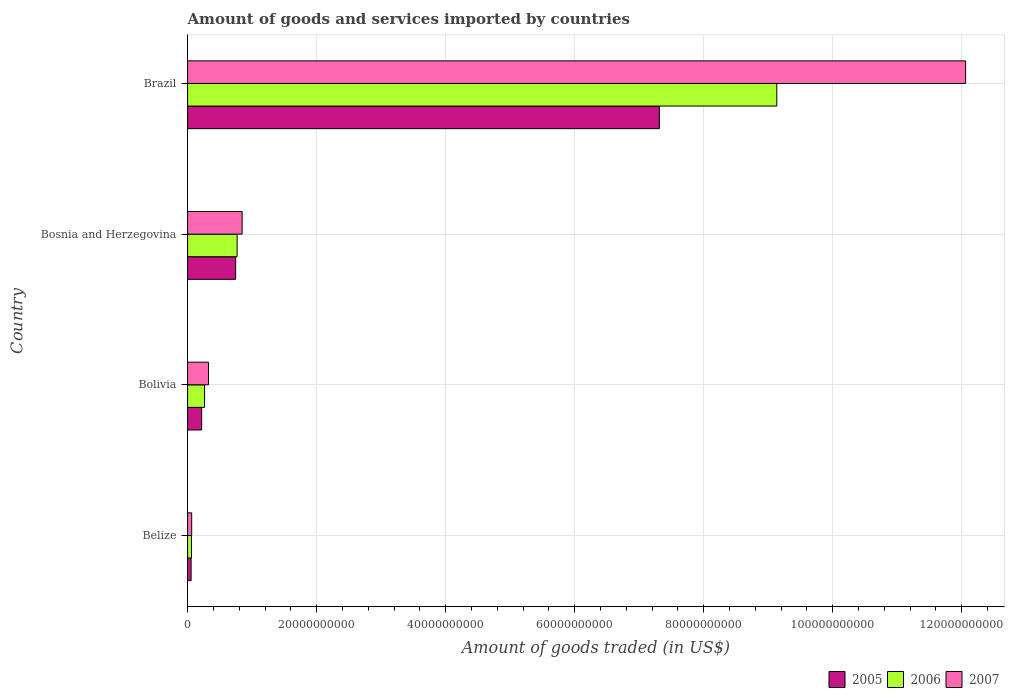How many different coloured bars are there?
Ensure brevity in your answer.  3. Are the number of bars per tick equal to the number of legend labels?
Provide a succinct answer. Yes. Are the number of bars on each tick of the Y-axis equal?
Offer a terse response. Yes. How many bars are there on the 3rd tick from the top?
Your response must be concise. 3. What is the label of the 1st group of bars from the top?
Your answer should be very brief. Brazil. What is the total amount of goods and services imported in 2005 in Bosnia and Herzegovina?
Offer a terse response. 7.45e+09. Across all countries, what is the maximum total amount of goods and services imported in 2006?
Provide a succinct answer. 9.13e+1. Across all countries, what is the minimum total amount of goods and services imported in 2007?
Your answer should be compact. 6.35e+08. In which country was the total amount of goods and services imported in 2006 minimum?
Give a very brief answer. Belize. What is the total total amount of goods and services imported in 2006 in the graph?
Your answer should be compact. 1.02e+11. What is the difference between the total amount of goods and services imported in 2007 in Belize and that in Bosnia and Herzegovina?
Your response must be concise. -7.82e+09. What is the difference between the total amount of goods and services imported in 2007 in Bosnia and Herzegovina and the total amount of goods and services imported in 2006 in Brazil?
Keep it short and to the point. -8.29e+1. What is the average total amount of goods and services imported in 2005 per country?
Your response must be concise. 2.08e+1. What is the difference between the total amount of goods and services imported in 2007 and total amount of goods and services imported in 2006 in Bolivia?
Your answer should be compact. 6.11e+08. What is the ratio of the total amount of goods and services imported in 2007 in Bolivia to that in Bosnia and Herzegovina?
Provide a short and direct response. 0.38. Is the total amount of goods and services imported in 2006 in Belize less than that in Brazil?
Provide a short and direct response. Yes. What is the difference between the highest and the second highest total amount of goods and services imported in 2006?
Your response must be concise. 8.37e+1. What is the difference between the highest and the lowest total amount of goods and services imported in 2006?
Keep it short and to the point. 9.08e+1. Is it the case that in every country, the sum of the total amount of goods and services imported in 2005 and total amount of goods and services imported in 2006 is greater than the total amount of goods and services imported in 2007?
Make the answer very short. Yes. Are all the bars in the graph horizontal?
Your answer should be very brief. Yes. How many countries are there in the graph?
Offer a terse response. 4. What is the difference between two consecutive major ticks on the X-axis?
Your response must be concise. 2.00e+1. Are the values on the major ticks of X-axis written in scientific E-notation?
Your response must be concise. No. Does the graph contain any zero values?
Provide a short and direct response. No. Does the graph contain grids?
Provide a short and direct response. Yes. What is the title of the graph?
Your answer should be very brief. Amount of goods and services imported by countries. Does "1982" appear as one of the legend labels in the graph?
Keep it short and to the point. No. What is the label or title of the X-axis?
Your answer should be compact. Amount of goods traded (in US$). What is the Amount of goods traded (in US$) of 2005 in Belize?
Make the answer very short. 5.44e+08. What is the Amount of goods traded (in US$) in 2006 in Belize?
Ensure brevity in your answer.  5.98e+08. What is the Amount of goods traded (in US$) in 2007 in Belize?
Ensure brevity in your answer.  6.35e+08. What is the Amount of goods traded (in US$) in 2005 in Bolivia?
Give a very brief answer. 2.18e+09. What is the Amount of goods traded (in US$) of 2006 in Bolivia?
Your answer should be compact. 2.63e+09. What is the Amount of goods traded (in US$) of 2007 in Bolivia?
Your answer should be very brief. 3.24e+09. What is the Amount of goods traded (in US$) in 2005 in Bosnia and Herzegovina?
Give a very brief answer. 7.45e+09. What is the Amount of goods traded (in US$) in 2006 in Bosnia and Herzegovina?
Keep it short and to the point. 7.68e+09. What is the Amount of goods traded (in US$) of 2007 in Bosnia and Herzegovina?
Your answer should be compact. 8.45e+09. What is the Amount of goods traded (in US$) in 2005 in Brazil?
Keep it short and to the point. 7.31e+1. What is the Amount of goods traded (in US$) of 2006 in Brazil?
Offer a terse response. 9.13e+1. What is the Amount of goods traded (in US$) of 2007 in Brazil?
Your response must be concise. 1.21e+11. Across all countries, what is the maximum Amount of goods traded (in US$) of 2005?
Offer a very short reply. 7.31e+1. Across all countries, what is the maximum Amount of goods traded (in US$) in 2006?
Offer a terse response. 9.13e+1. Across all countries, what is the maximum Amount of goods traded (in US$) of 2007?
Offer a terse response. 1.21e+11. Across all countries, what is the minimum Amount of goods traded (in US$) of 2005?
Offer a very short reply. 5.44e+08. Across all countries, what is the minimum Amount of goods traded (in US$) of 2006?
Your response must be concise. 5.98e+08. Across all countries, what is the minimum Amount of goods traded (in US$) in 2007?
Offer a terse response. 6.35e+08. What is the total Amount of goods traded (in US$) in 2005 in the graph?
Offer a terse response. 8.33e+1. What is the total Amount of goods traded (in US$) in 2006 in the graph?
Ensure brevity in your answer.  1.02e+11. What is the total Amount of goods traded (in US$) in 2007 in the graph?
Offer a very short reply. 1.33e+11. What is the difference between the Amount of goods traded (in US$) of 2005 in Belize and that in Bolivia?
Provide a succinct answer. -1.64e+09. What is the difference between the Amount of goods traded (in US$) in 2006 in Belize and that in Bolivia?
Make the answer very short. -2.03e+09. What is the difference between the Amount of goods traded (in US$) in 2007 in Belize and that in Bolivia?
Offer a terse response. -2.61e+09. What is the difference between the Amount of goods traded (in US$) of 2005 in Belize and that in Bosnia and Herzegovina?
Provide a short and direct response. -6.91e+09. What is the difference between the Amount of goods traded (in US$) of 2006 in Belize and that in Bosnia and Herzegovina?
Provide a succinct answer. -7.08e+09. What is the difference between the Amount of goods traded (in US$) in 2007 in Belize and that in Bosnia and Herzegovina?
Provide a succinct answer. -7.82e+09. What is the difference between the Amount of goods traded (in US$) in 2005 in Belize and that in Brazil?
Give a very brief answer. -7.26e+1. What is the difference between the Amount of goods traded (in US$) in 2006 in Belize and that in Brazil?
Offer a terse response. -9.08e+1. What is the difference between the Amount of goods traded (in US$) in 2007 in Belize and that in Brazil?
Your answer should be compact. -1.20e+11. What is the difference between the Amount of goods traded (in US$) in 2005 in Bolivia and that in Bosnia and Herzegovina?
Offer a very short reply. -5.27e+09. What is the difference between the Amount of goods traded (in US$) in 2006 in Bolivia and that in Bosnia and Herzegovina?
Give a very brief answer. -5.05e+09. What is the difference between the Amount of goods traded (in US$) of 2007 in Bolivia and that in Bosnia and Herzegovina?
Give a very brief answer. -5.21e+09. What is the difference between the Amount of goods traded (in US$) in 2005 in Bolivia and that in Brazil?
Offer a terse response. -7.10e+1. What is the difference between the Amount of goods traded (in US$) in 2006 in Bolivia and that in Brazil?
Offer a very short reply. -8.87e+1. What is the difference between the Amount of goods traded (in US$) of 2007 in Bolivia and that in Brazil?
Offer a terse response. -1.17e+11. What is the difference between the Amount of goods traded (in US$) in 2005 in Bosnia and Herzegovina and that in Brazil?
Your response must be concise. -6.57e+1. What is the difference between the Amount of goods traded (in US$) in 2006 in Bosnia and Herzegovina and that in Brazil?
Make the answer very short. -8.37e+1. What is the difference between the Amount of goods traded (in US$) of 2007 in Bosnia and Herzegovina and that in Brazil?
Give a very brief answer. -1.12e+11. What is the difference between the Amount of goods traded (in US$) in 2005 in Belize and the Amount of goods traded (in US$) in 2006 in Bolivia?
Keep it short and to the point. -2.09e+09. What is the difference between the Amount of goods traded (in US$) in 2005 in Belize and the Amount of goods traded (in US$) in 2007 in Bolivia?
Your answer should be compact. -2.70e+09. What is the difference between the Amount of goods traded (in US$) of 2006 in Belize and the Amount of goods traded (in US$) of 2007 in Bolivia?
Keep it short and to the point. -2.65e+09. What is the difference between the Amount of goods traded (in US$) of 2005 in Belize and the Amount of goods traded (in US$) of 2006 in Bosnia and Herzegovina?
Give a very brief answer. -7.14e+09. What is the difference between the Amount of goods traded (in US$) of 2005 in Belize and the Amount of goods traded (in US$) of 2007 in Bosnia and Herzegovina?
Provide a succinct answer. -7.91e+09. What is the difference between the Amount of goods traded (in US$) of 2006 in Belize and the Amount of goods traded (in US$) of 2007 in Bosnia and Herzegovina?
Provide a short and direct response. -7.86e+09. What is the difference between the Amount of goods traded (in US$) of 2005 in Belize and the Amount of goods traded (in US$) of 2006 in Brazil?
Give a very brief answer. -9.08e+1. What is the difference between the Amount of goods traded (in US$) in 2005 in Belize and the Amount of goods traded (in US$) in 2007 in Brazil?
Your answer should be compact. -1.20e+11. What is the difference between the Amount of goods traded (in US$) of 2006 in Belize and the Amount of goods traded (in US$) of 2007 in Brazil?
Your answer should be very brief. -1.20e+11. What is the difference between the Amount of goods traded (in US$) of 2005 in Bolivia and the Amount of goods traded (in US$) of 2006 in Bosnia and Herzegovina?
Your answer should be very brief. -5.50e+09. What is the difference between the Amount of goods traded (in US$) of 2005 in Bolivia and the Amount of goods traded (in US$) of 2007 in Bosnia and Herzegovina?
Keep it short and to the point. -6.27e+09. What is the difference between the Amount of goods traded (in US$) of 2006 in Bolivia and the Amount of goods traded (in US$) of 2007 in Bosnia and Herzegovina?
Offer a very short reply. -5.82e+09. What is the difference between the Amount of goods traded (in US$) of 2005 in Bolivia and the Amount of goods traded (in US$) of 2006 in Brazil?
Make the answer very short. -8.92e+1. What is the difference between the Amount of goods traded (in US$) in 2005 in Bolivia and the Amount of goods traded (in US$) in 2007 in Brazil?
Offer a very short reply. -1.18e+11. What is the difference between the Amount of goods traded (in US$) of 2006 in Bolivia and the Amount of goods traded (in US$) of 2007 in Brazil?
Make the answer very short. -1.18e+11. What is the difference between the Amount of goods traded (in US$) of 2005 in Bosnia and Herzegovina and the Amount of goods traded (in US$) of 2006 in Brazil?
Ensure brevity in your answer.  -8.39e+1. What is the difference between the Amount of goods traded (in US$) of 2005 in Bosnia and Herzegovina and the Amount of goods traded (in US$) of 2007 in Brazil?
Offer a terse response. -1.13e+11. What is the difference between the Amount of goods traded (in US$) in 2006 in Bosnia and Herzegovina and the Amount of goods traded (in US$) in 2007 in Brazil?
Offer a very short reply. -1.13e+11. What is the average Amount of goods traded (in US$) of 2005 per country?
Offer a very short reply. 2.08e+1. What is the average Amount of goods traded (in US$) of 2006 per country?
Provide a succinct answer. 2.56e+1. What is the average Amount of goods traded (in US$) of 2007 per country?
Ensure brevity in your answer.  3.32e+1. What is the difference between the Amount of goods traded (in US$) of 2005 and Amount of goods traded (in US$) of 2006 in Belize?
Keep it short and to the point. -5.37e+07. What is the difference between the Amount of goods traded (in US$) in 2005 and Amount of goods traded (in US$) in 2007 in Belize?
Your answer should be very brief. -9.05e+07. What is the difference between the Amount of goods traded (in US$) in 2006 and Amount of goods traded (in US$) in 2007 in Belize?
Make the answer very short. -3.68e+07. What is the difference between the Amount of goods traded (in US$) of 2005 and Amount of goods traded (in US$) of 2006 in Bolivia?
Provide a succinct answer. -4.50e+08. What is the difference between the Amount of goods traded (in US$) of 2005 and Amount of goods traded (in US$) of 2007 in Bolivia?
Make the answer very short. -1.06e+09. What is the difference between the Amount of goods traded (in US$) in 2006 and Amount of goods traded (in US$) in 2007 in Bolivia?
Give a very brief answer. -6.11e+08. What is the difference between the Amount of goods traded (in US$) of 2005 and Amount of goods traded (in US$) of 2006 in Bosnia and Herzegovina?
Give a very brief answer. -2.25e+08. What is the difference between the Amount of goods traded (in US$) in 2005 and Amount of goods traded (in US$) in 2007 in Bosnia and Herzegovina?
Make the answer very short. -1.00e+09. What is the difference between the Amount of goods traded (in US$) of 2006 and Amount of goods traded (in US$) of 2007 in Bosnia and Herzegovina?
Ensure brevity in your answer.  -7.75e+08. What is the difference between the Amount of goods traded (in US$) in 2005 and Amount of goods traded (in US$) in 2006 in Brazil?
Offer a very short reply. -1.82e+1. What is the difference between the Amount of goods traded (in US$) of 2005 and Amount of goods traded (in US$) of 2007 in Brazil?
Offer a very short reply. -4.75e+1. What is the difference between the Amount of goods traded (in US$) of 2006 and Amount of goods traded (in US$) of 2007 in Brazil?
Your answer should be very brief. -2.93e+1. What is the ratio of the Amount of goods traded (in US$) in 2005 in Belize to that in Bolivia?
Offer a terse response. 0.25. What is the ratio of the Amount of goods traded (in US$) of 2006 in Belize to that in Bolivia?
Give a very brief answer. 0.23. What is the ratio of the Amount of goods traded (in US$) in 2007 in Belize to that in Bolivia?
Make the answer very short. 0.2. What is the ratio of the Amount of goods traded (in US$) in 2005 in Belize to that in Bosnia and Herzegovina?
Your answer should be very brief. 0.07. What is the ratio of the Amount of goods traded (in US$) in 2006 in Belize to that in Bosnia and Herzegovina?
Ensure brevity in your answer.  0.08. What is the ratio of the Amount of goods traded (in US$) in 2007 in Belize to that in Bosnia and Herzegovina?
Make the answer very short. 0.08. What is the ratio of the Amount of goods traded (in US$) of 2005 in Belize to that in Brazil?
Provide a succinct answer. 0.01. What is the ratio of the Amount of goods traded (in US$) in 2006 in Belize to that in Brazil?
Keep it short and to the point. 0.01. What is the ratio of the Amount of goods traded (in US$) of 2007 in Belize to that in Brazil?
Give a very brief answer. 0.01. What is the ratio of the Amount of goods traded (in US$) in 2005 in Bolivia to that in Bosnia and Herzegovina?
Give a very brief answer. 0.29. What is the ratio of the Amount of goods traded (in US$) in 2006 in Bolivia to that in Bosnia and Herzegovina?
Keep it short and to the point. 0.34. What is the ratio of the Amount of goods traded (in US$) in 2007 in Bolivia to that in Bosnia and Herzegovina?
Ensure brevity in your answer.  0.38. What is the ratio of the Amount of goods traded (in US$) in 2005 in Bolivia to that in Brazil?
Offer a very short reply. 0.03. What is the ratio of the Amount of goods traded (in US$) in 2006 in Bolivia to that in Brazil?
Provide a short and direct response. 0.03. What is the ratio of the Amount of goods traded (in US$) in 2007 in Bolivia to that in Brazil?
Make the answer very short. 0.03. What is the ratio of the Amount of goods traded (in US$) in 2005 in Bosnia and Herzegovina to that in Brazil?
Your answer should be very brief. 0.1. What is the ratio of the Amount of goods traded (in US$) of 2006 in Bosnia and Herzegovina to that in Brazil?
Offer a terse response. 0.08. What is the ratio of the Amount of goods traded (in US$) of 2007 in Bosnia and Herzegovina to that in Brazil?
Ensure brevity in your answer.  0.07. What is the difference between the highest and the second highest Amount of goods traded (in US$) of 2005?
Make the answer very short. 6.57e+1. What is the difference between the highest and the second highest Amount of goods traded (in US$) in 2006?
Provide a succinct answer. 8.37e+1. What is the difference between the highest and the second highest Amount of goods traded (in US$) of 2007?
Make the answer very short. 1.12e+11. What is the difference between the highest and the lowest Amount of goods traded (in US$) in 2005?
Give a very brief answer. 7.26e+1. What is the difference between the highest and the lowest Amount of goods traded (in US$) of 2006?
Your answer should be very brief. 9.08e+1. What is the difference between the highest and the lowest Amount of goods traded (in US$) in 2007?
Keep it short and to the point. 1.20e+11. 